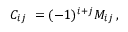Convert formula to latex. <formula><loc_0><loc_0><loc_500><loc_500>C _ { i j } \ = ( - 1 ) ^ { i + j } M _ { i j } \, ,</formula> 